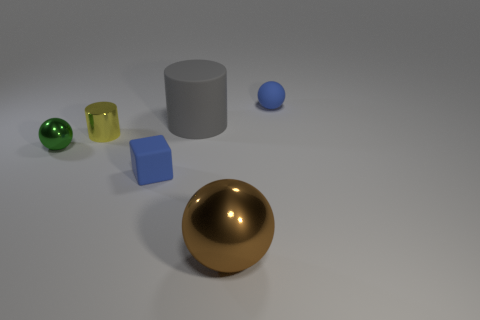Is the color of the block the same as the small matte ball?
Ensure brevity in your answer.  Yes. What is the shape of the thing that is on the right side of the big cylinder and in front of the matte sphere?
Ensure brevity in your answer.  Sphere. Are there any small rubber things of the same color as the block?
Give a very brief answer. Yes. Are there any shiny objects?
Provide a short and direct response. Yes. What is the color of the tiny matte thing that is in front of the large rubber cylinder?
Your response must be concise. Blue. Does the blue rubber cube have the same size as the sphere left of the big shiny ball?
Your answer should be very brief. Yes. How big is the sphere that is both behind the small blue rubber block and right of the blue matte block?
Offer a very short reply. Small. Is there a large green cylinder that has the same material as the gray cylinder?
Give a very brief answer. No. What is the shape of the small yellow shiny thing?
Offer a terse response. Cylinder. Is the size of the brown sphere the same as the yellow metallic object?
Offer a very short reply. No. 